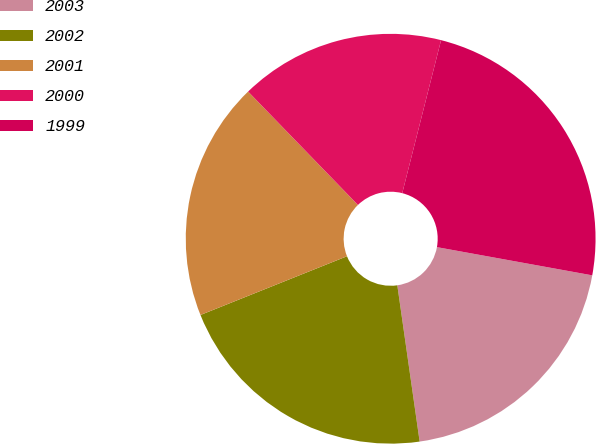Convert chart. <chart><loc_0><loc_0><loc_500><loc_500><pie_chart><fcel>2003<fcel>2002<fcel>2001<fcel>2000<fcel>1999<nl><fcel>19.88%<fcel>21.19%<fcel>18.82%<fcel>16.2%<fcel>23.9%<nl></chart> 